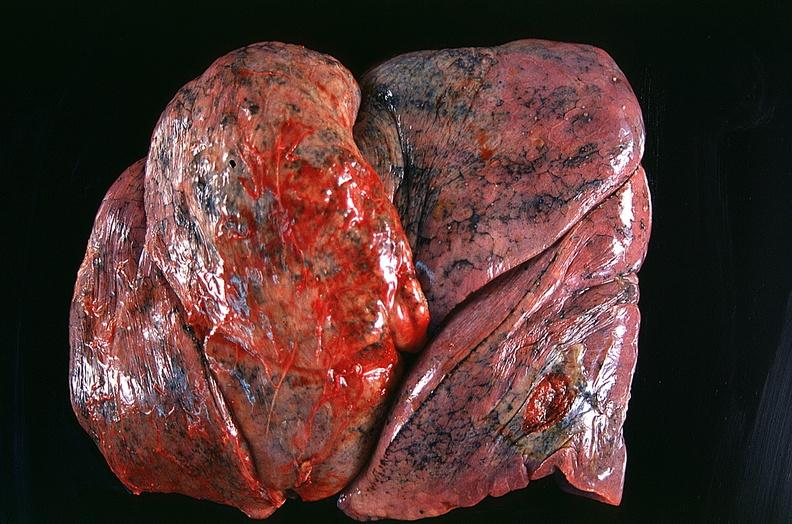what is present?
Answer the question using a single word or phrase. Respiratory 